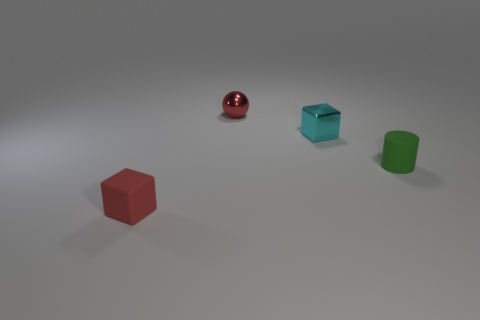Is the number of tiny green rubber cylinders less than the number of tiny cyan cylinders?
Provide a succinct answer. No. What number of tiny metallic blocks are on the right side of the tiny cube that is behind the tiny rubber object that is to the left of the small red ball?
Provide a short and direct response. 0. How big is the rubber thing that is to the left of the small rubber cylinder?
Make the answer very short. Small. There is a tiny thing behind the small cyan thing; does it have the same shape as the cyan thing?
Keep it short and to the point. No. There is a red thing that is the same shape as the cyan thing; what material is it?
Provide a succinct answer. Rubber. Is there any other thing that is the same size as the red rubber object?
Offer a very short reply. Yes. Is there a small red rubber block?
Ensure brevity in your answer.  Yes. What material is the small cube behind the matte object that is right of the cube behind the tiny green cylinder made of?
Provide a short and direct response. Metal. Is the shape of the tiny red matte object the same as the small shiny object right of the red shiny ball?
Keep it short and to the point. Yes. What number of other matte things are the same shape as the small red matte thing?
Provide a succinct answer. 0. 